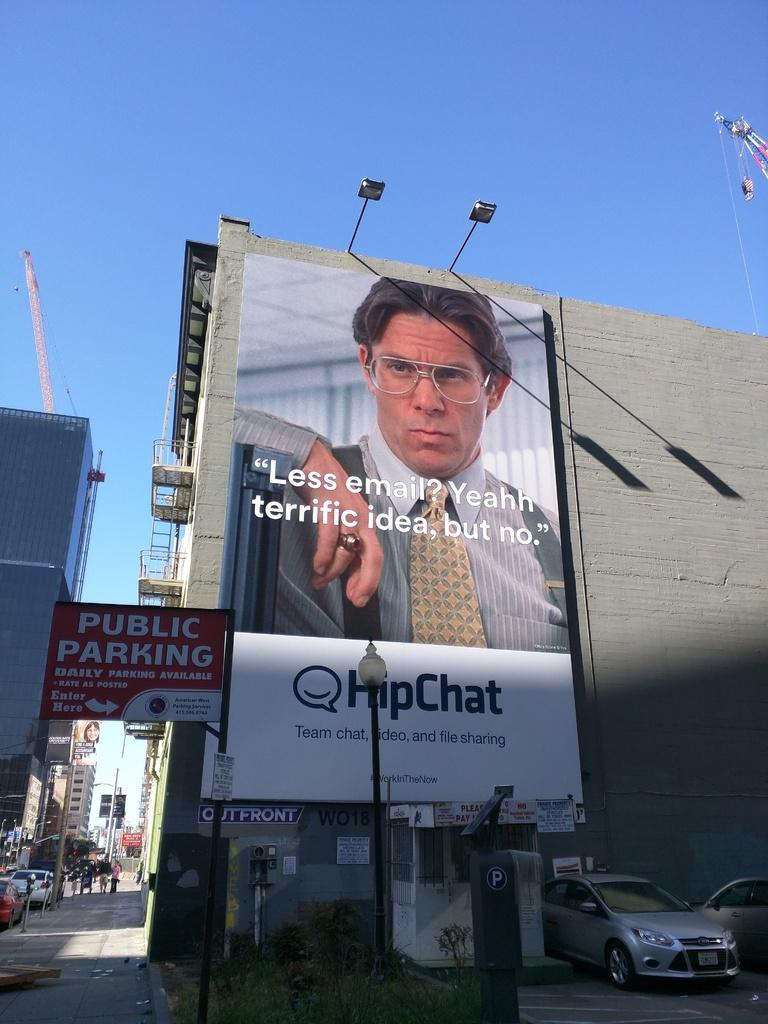<image>
Give a short and clear explanation of the subsequent image. A large billboard advertises HipChat with a man in glasses. 